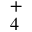Convert formula to latex. <formula><loc_0><loc_0><loc_500><loc_500>_ { 4 } ^ { + }</formula> 